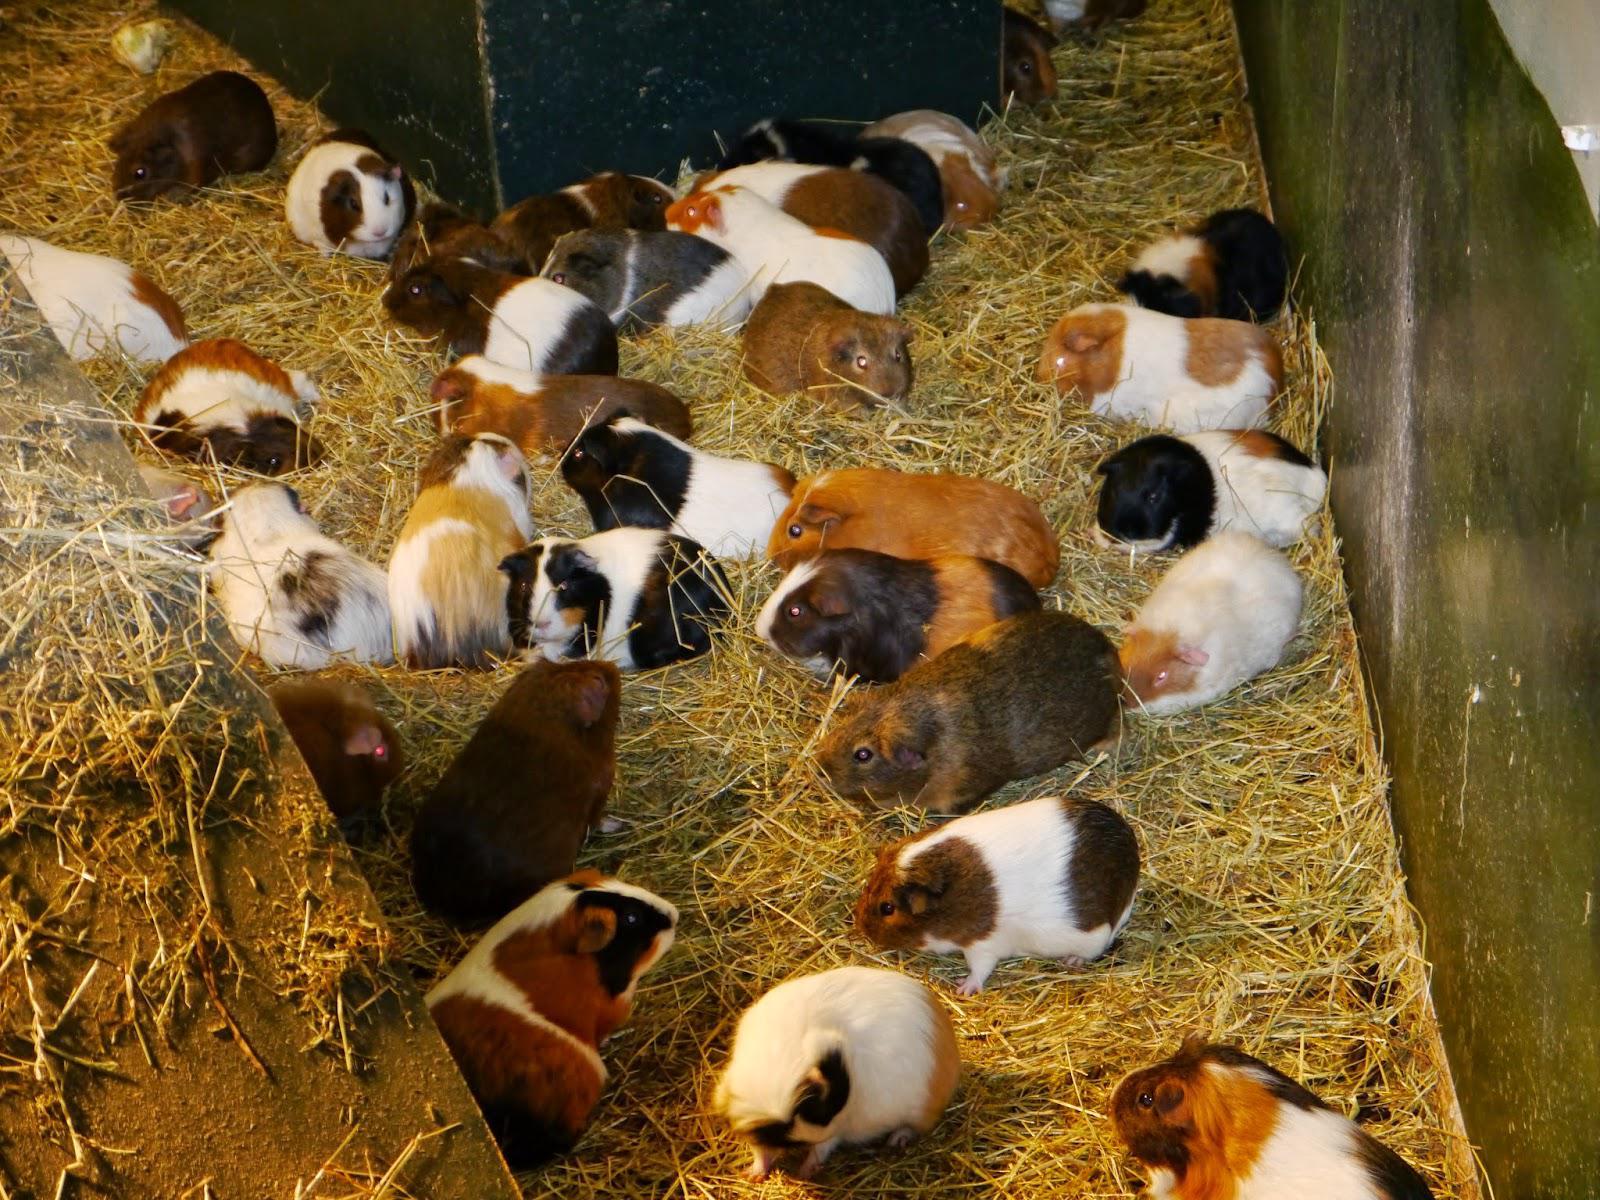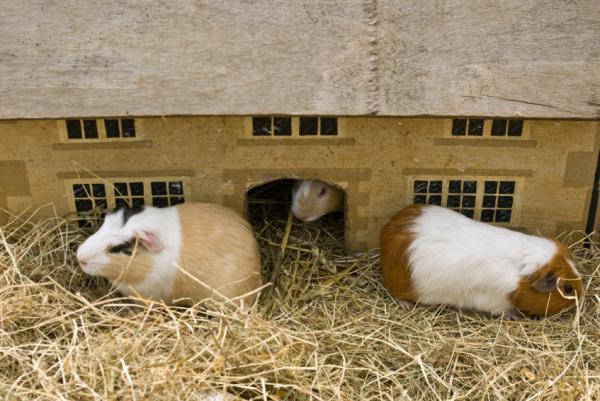The first image is the image on the left, the second image is the image on the right. Given the left and right images, does the statement "There is a bowl in the image on the right." hold true? Answer yes or no. No. 